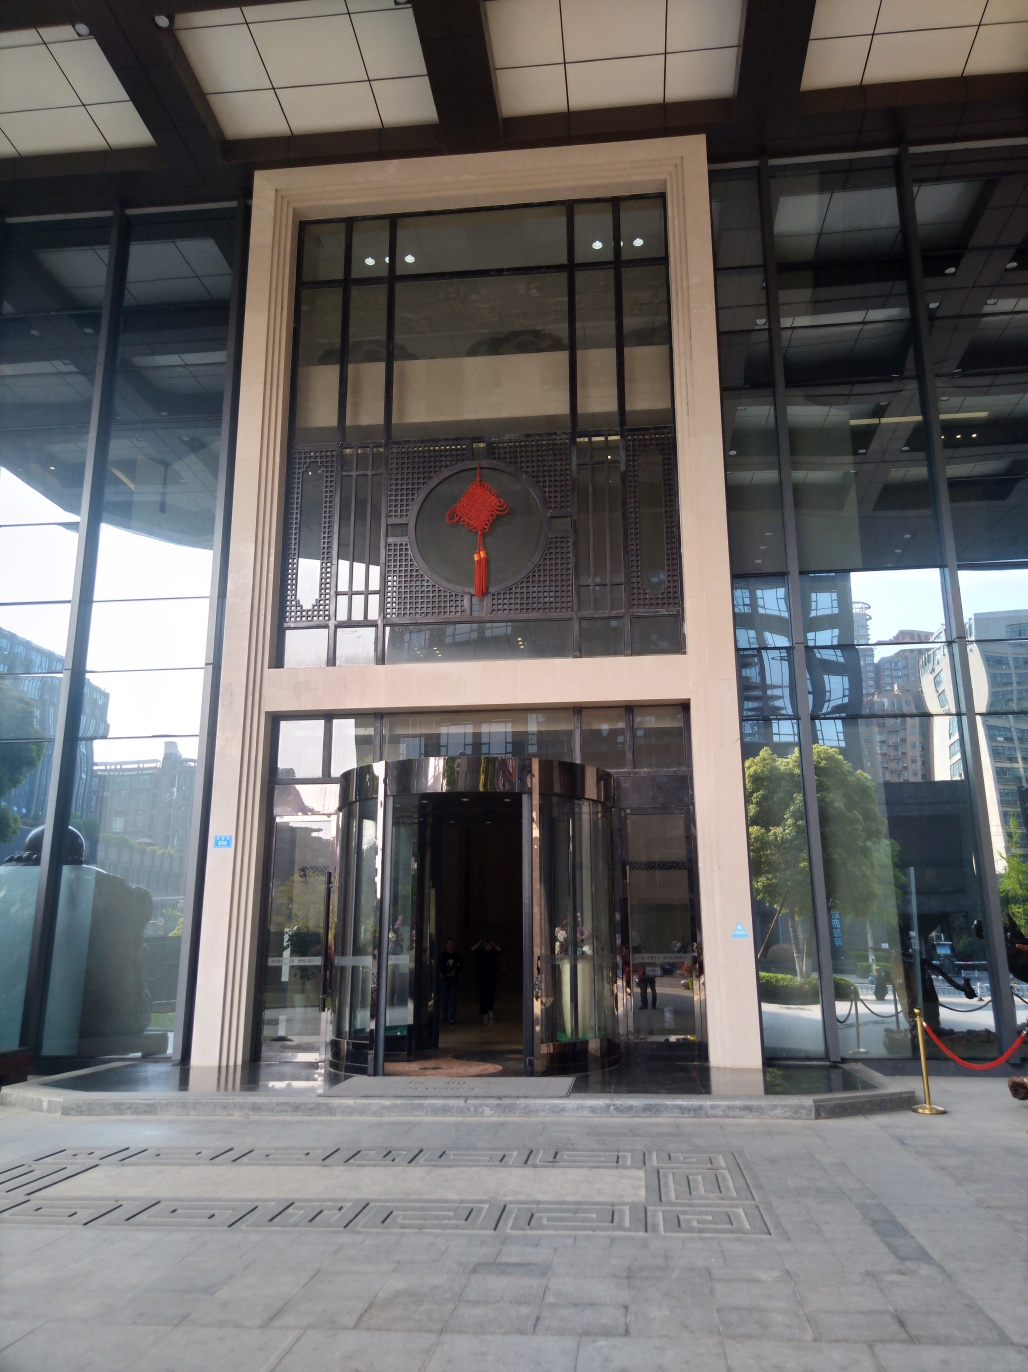What time of day does this photo appear to be taken? Judging by the shadows and the quality of light, the photo seems to have been taken in the late afternoon. The angle of the sunlight suggests it's not quite evening, as there are still bright areas and the overall visibility is good, although some parts are in shadow due to the position of the sun. 